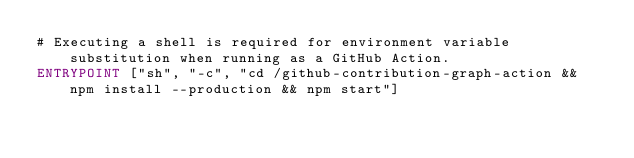Convert code to text. <code><loc_0><loc_0><loc_500><loc_500><_Dockerfile_># Executing a shell is required for environment variable substitution when running as a GitHub Action.
ENTRYPOINT ["sh", "-c", "cd /github-contribution-graph-action && npm install --production && npm start"]
</code> 